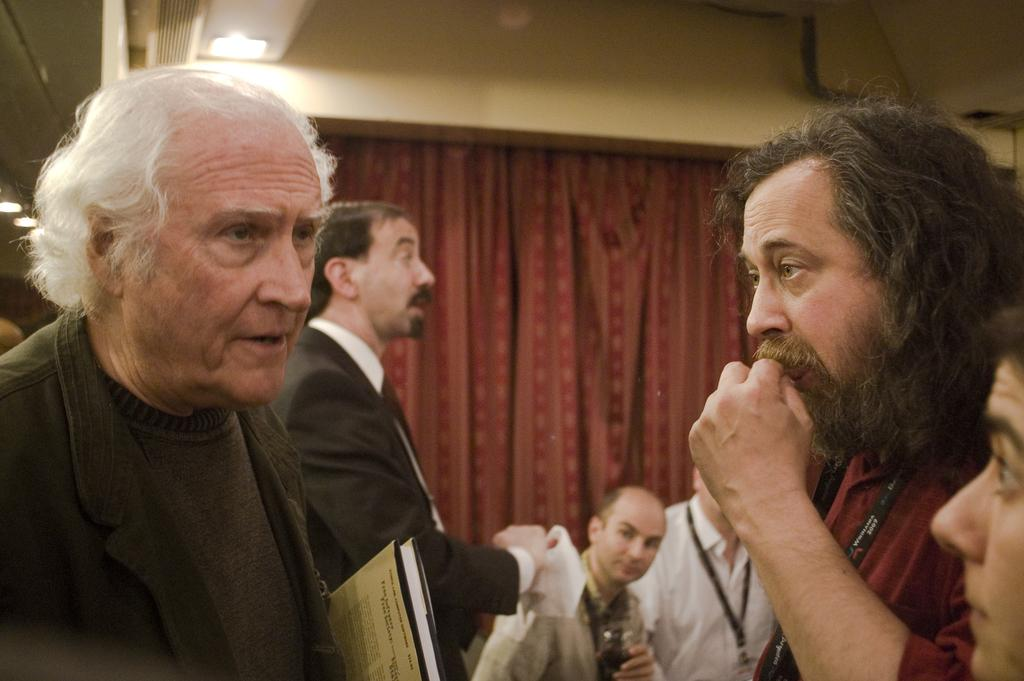Who or what can be seen in the image? There are people in the image. What items are present in the image that might be related to work or organization? There are files in the image. What other objects can be seen in the image? There are objects in the image, but their specific nature is not mentioned in the facts. What can be seen in the background of the image? There is a curtain, lights, a wall, and objects in the background of the image. Can you see any kites or icicles hanging from the wall in the image? No, there are no kites or icicles visible in the image. 